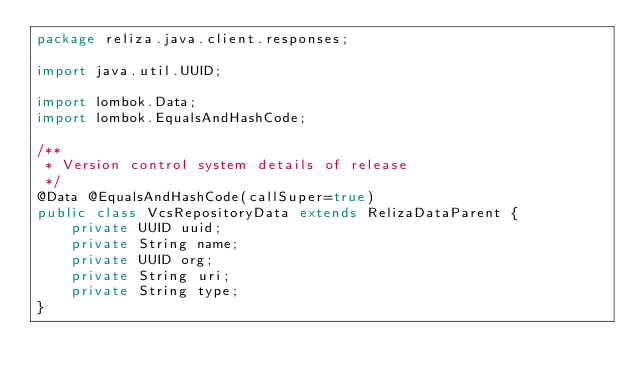Convert code to text. <code><loc_0><loc_0><loc_500><loc_500><_Java_>package reliza.java.client.responses;

import java.util.UUID;

import lombok.Data;
import lombok.EqualsAndHashCode;

/**
 * Version control system details of release
 */
@Data @EqualsAndHashCode(callSuper=true)
public class VcsRepositoryData extends RelizaDataParent {
	private UUID uuid;
	private String name;
	private UUID org;
	private String uri;
	private String type;
}</code> 